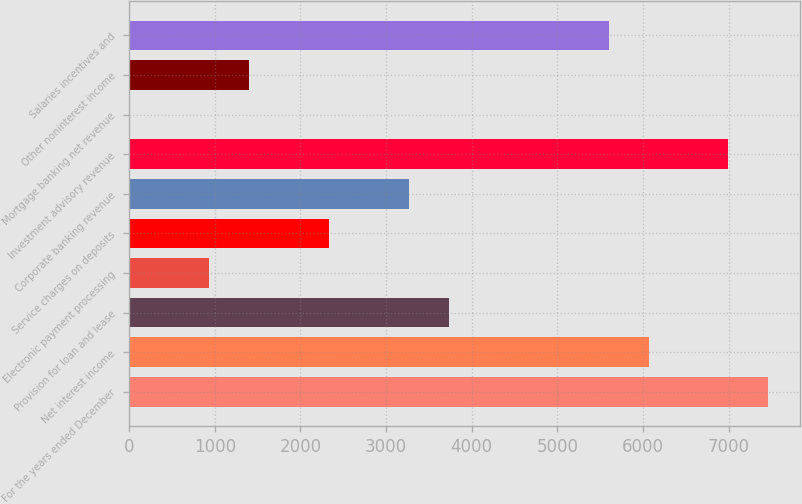<chart> <loc_0><loc_0><loc_500><loc_500><bar_chart><fcel>For the years ended December<fcel>Net interest income<fcel>Provision for loan and lease<fcel>Electronic payment processing<fcel>Service charges on deposits<fcel>Corporate banking revenue<fcel>Investment advisory revenue<fcel>Mortgage banking net revenue<fcel>Other noninterest income<fcel>Salaries incentives and<nl><fcel>7465<fcel>6065.5<fcel>3733<fcel>934<fcel>2333.5<fcel>3266.5<fcel>6998.5<fcel>1<fcel>1400.5<fcel>5599<nl></chart> 